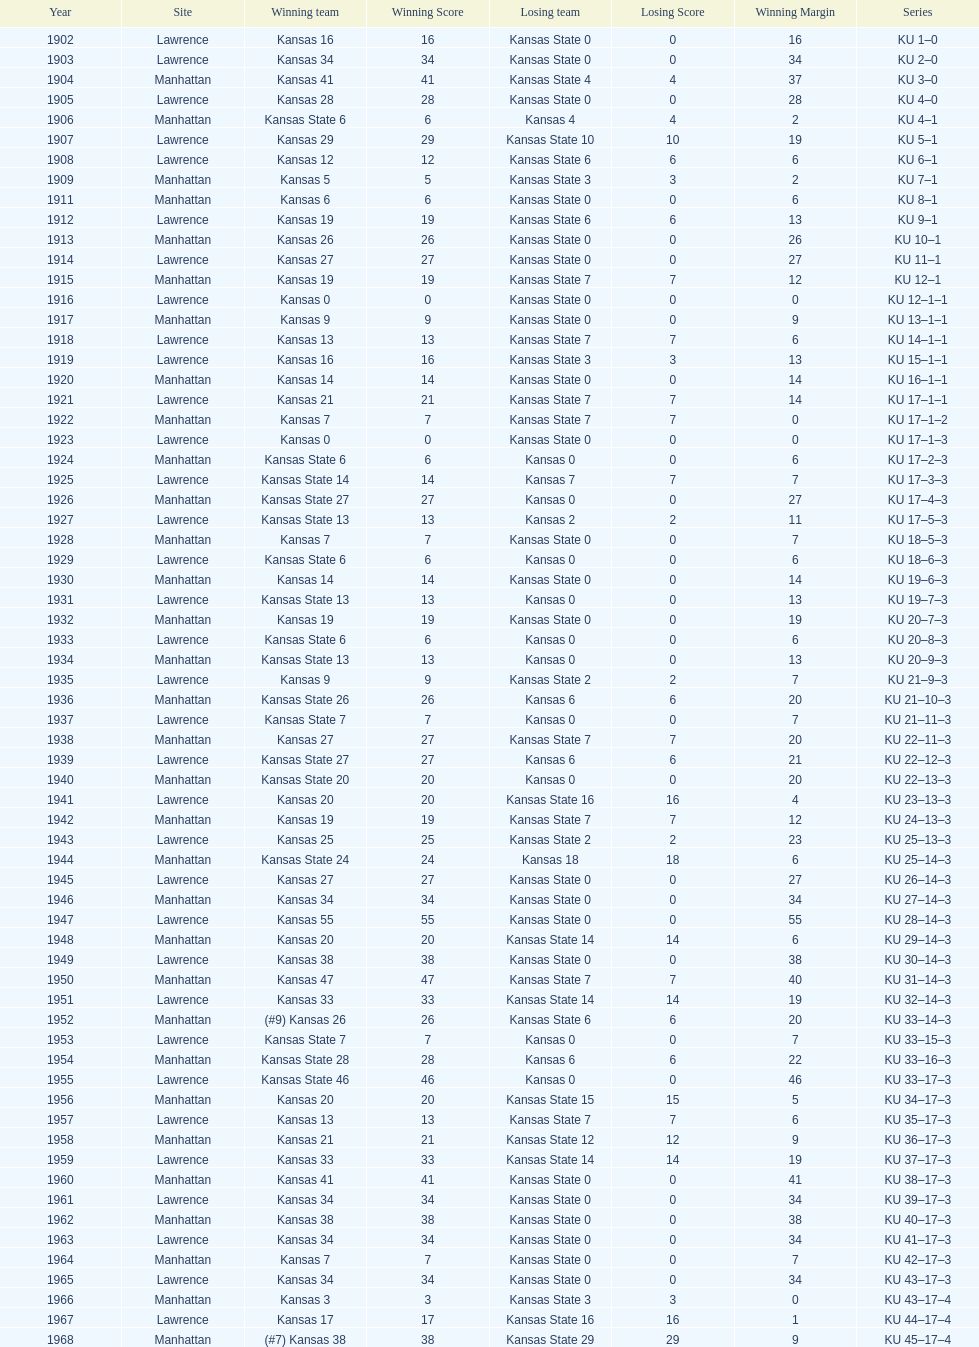What is the total number of games played? 66. 